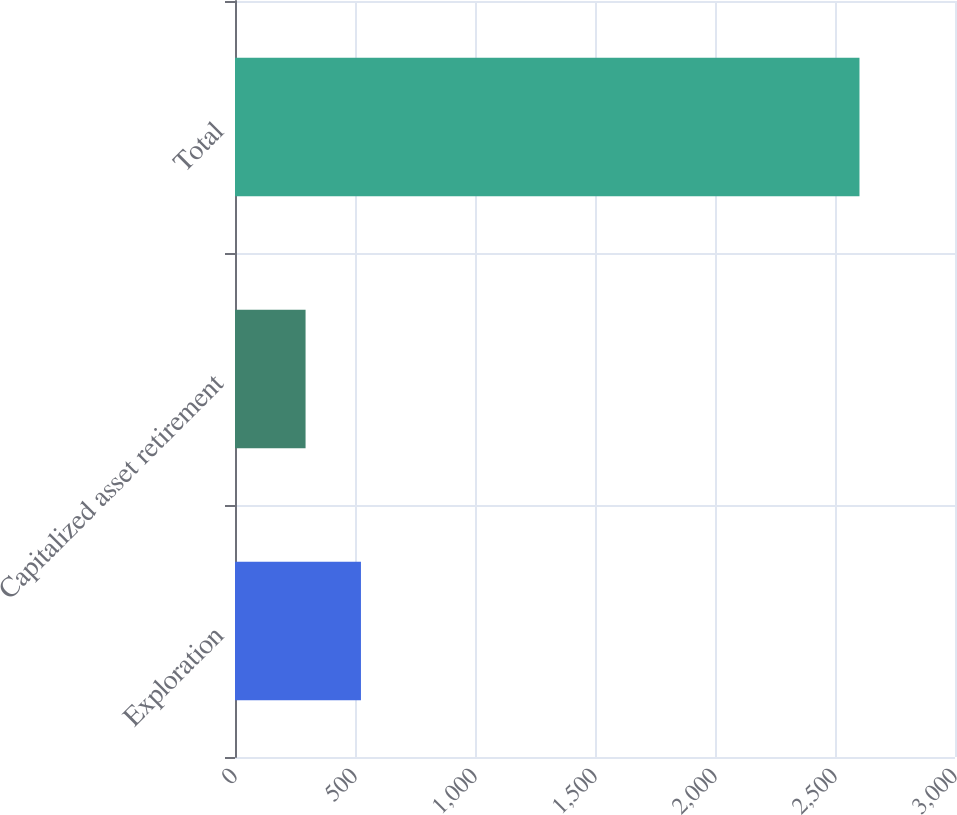Convert chart to OTSL. <chart><loc_0><loc_0><loc_500><loc_500><bar_chart><fcel>Exploration<fcel>Capitalized asset retirement<fcel>Total<nl><fcel>524.8<fcel>294<fcel>2602<nl></chart> 